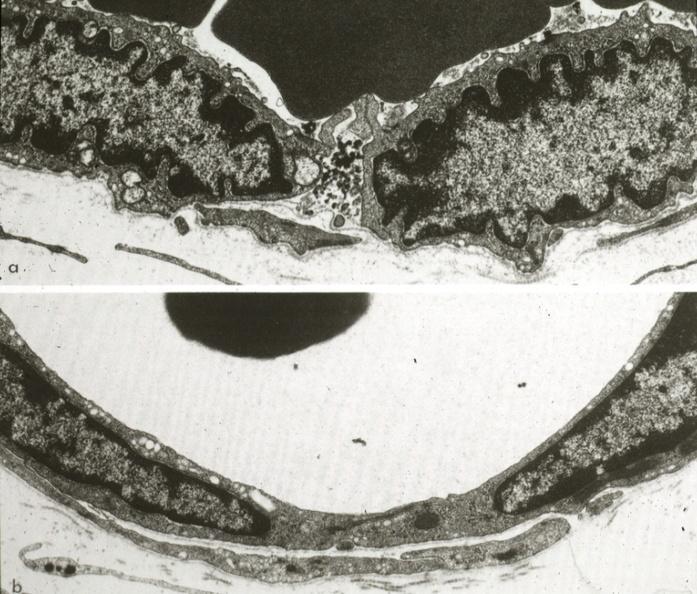s cardiovascular present?
Answer the question using a single word or phrase. Yes 